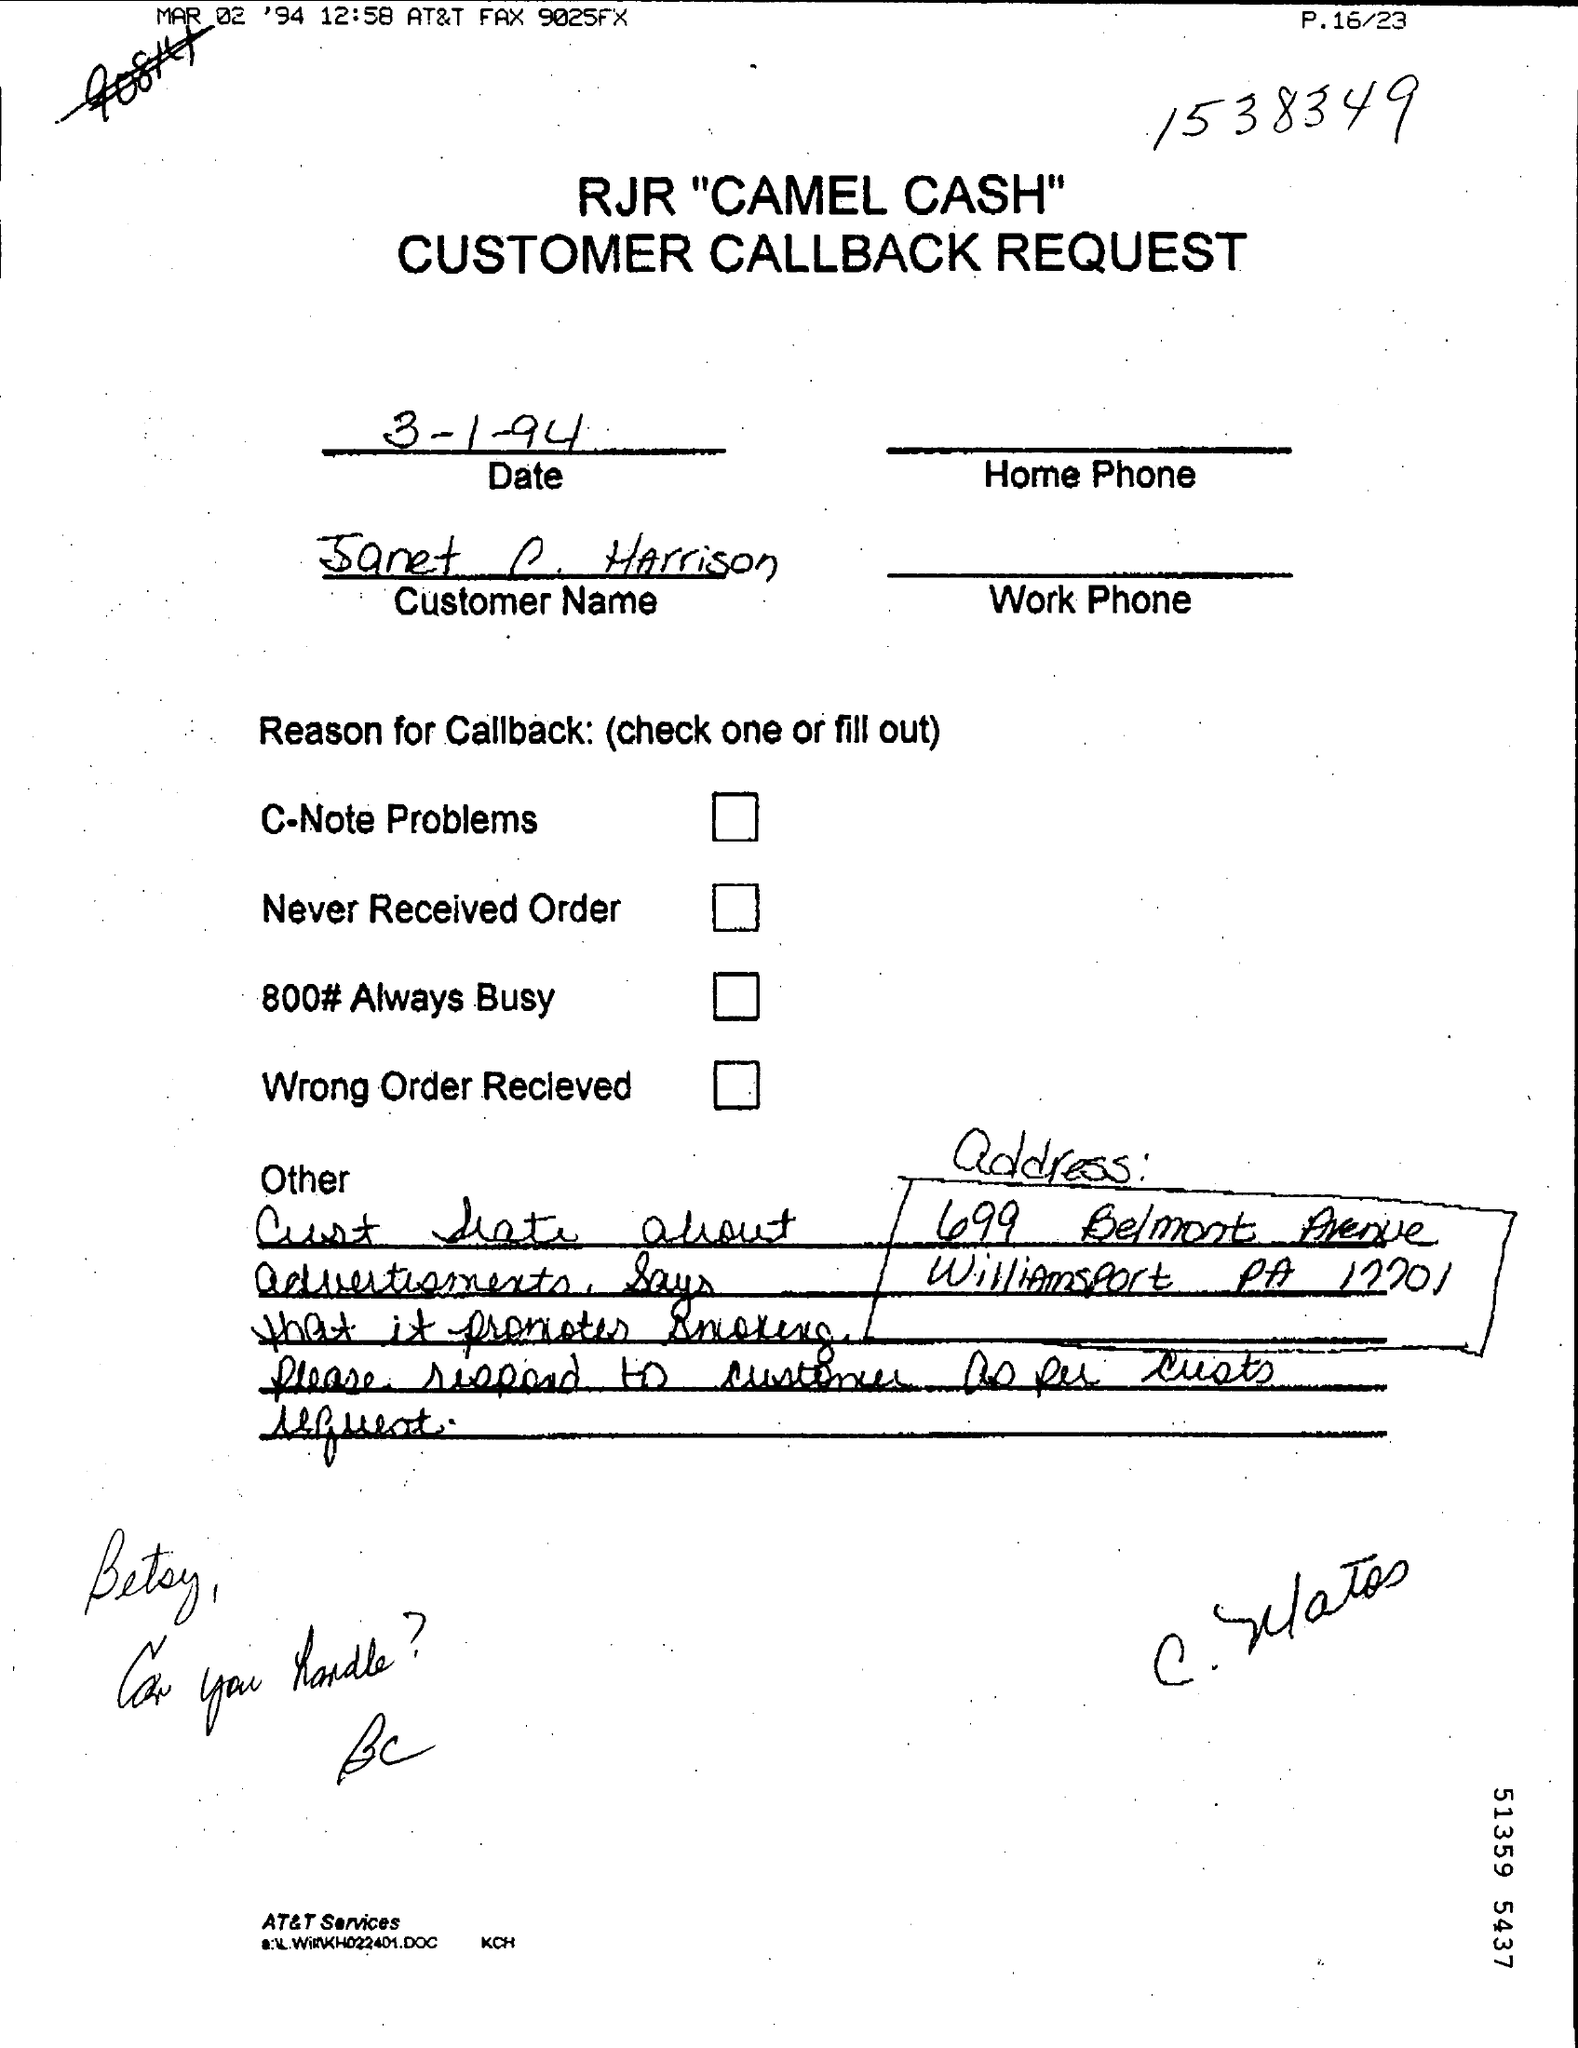What is the date mentioned in the page ?
Offer a very short reply. 3-1-94. What is the name of the request mentioned in the given page ?
Offer a very short reply. CUSTOMER CALLBACK REQUEST. 